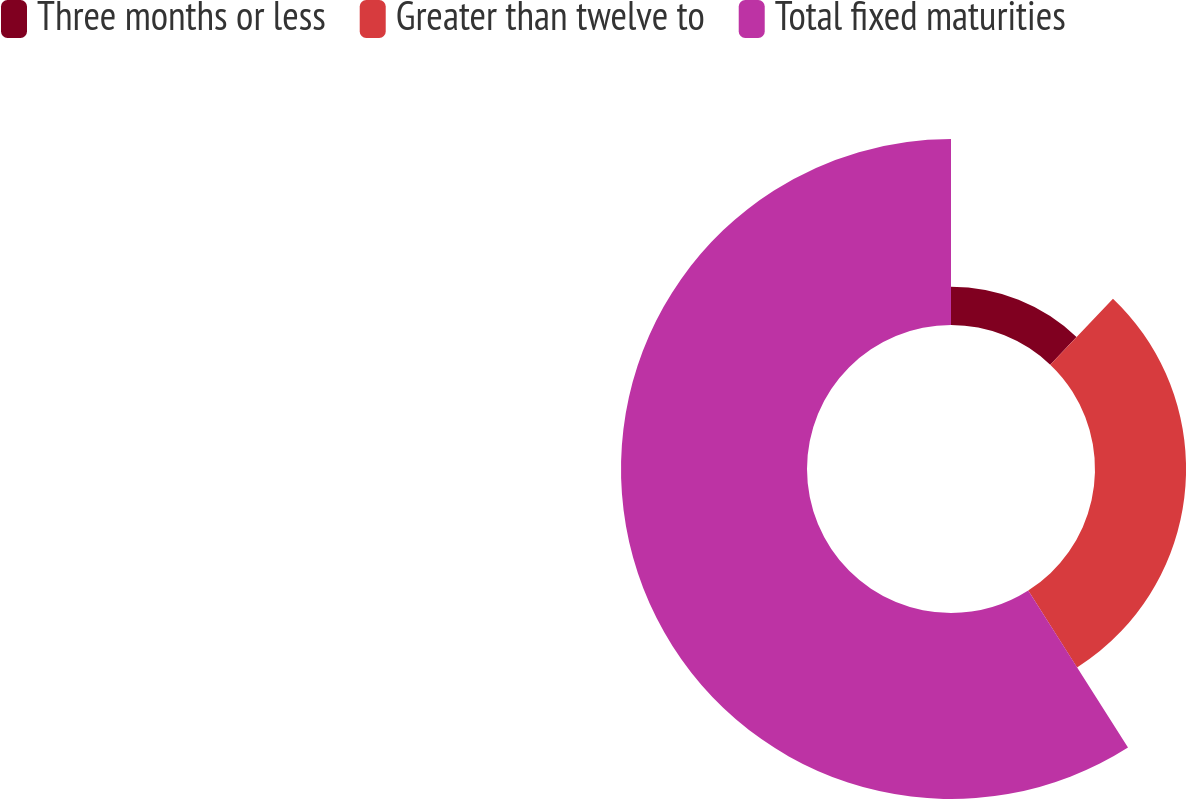<chart> <loc_0><loc_0><loc_500><loc_500><pie_chart><fcel>Three months or less<fcel>Greater than twelve to<fcel>Total fixed maturities<nl><fcel>12.1%<fcel>28.89%<fcel>59.01%<nl></chart> 